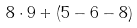Convert formula to latex. <formula><loc_0><loc_0><loc_500><loc_500>8 \cdot 9 + ( 5 - 6 - 8 )</formula> 